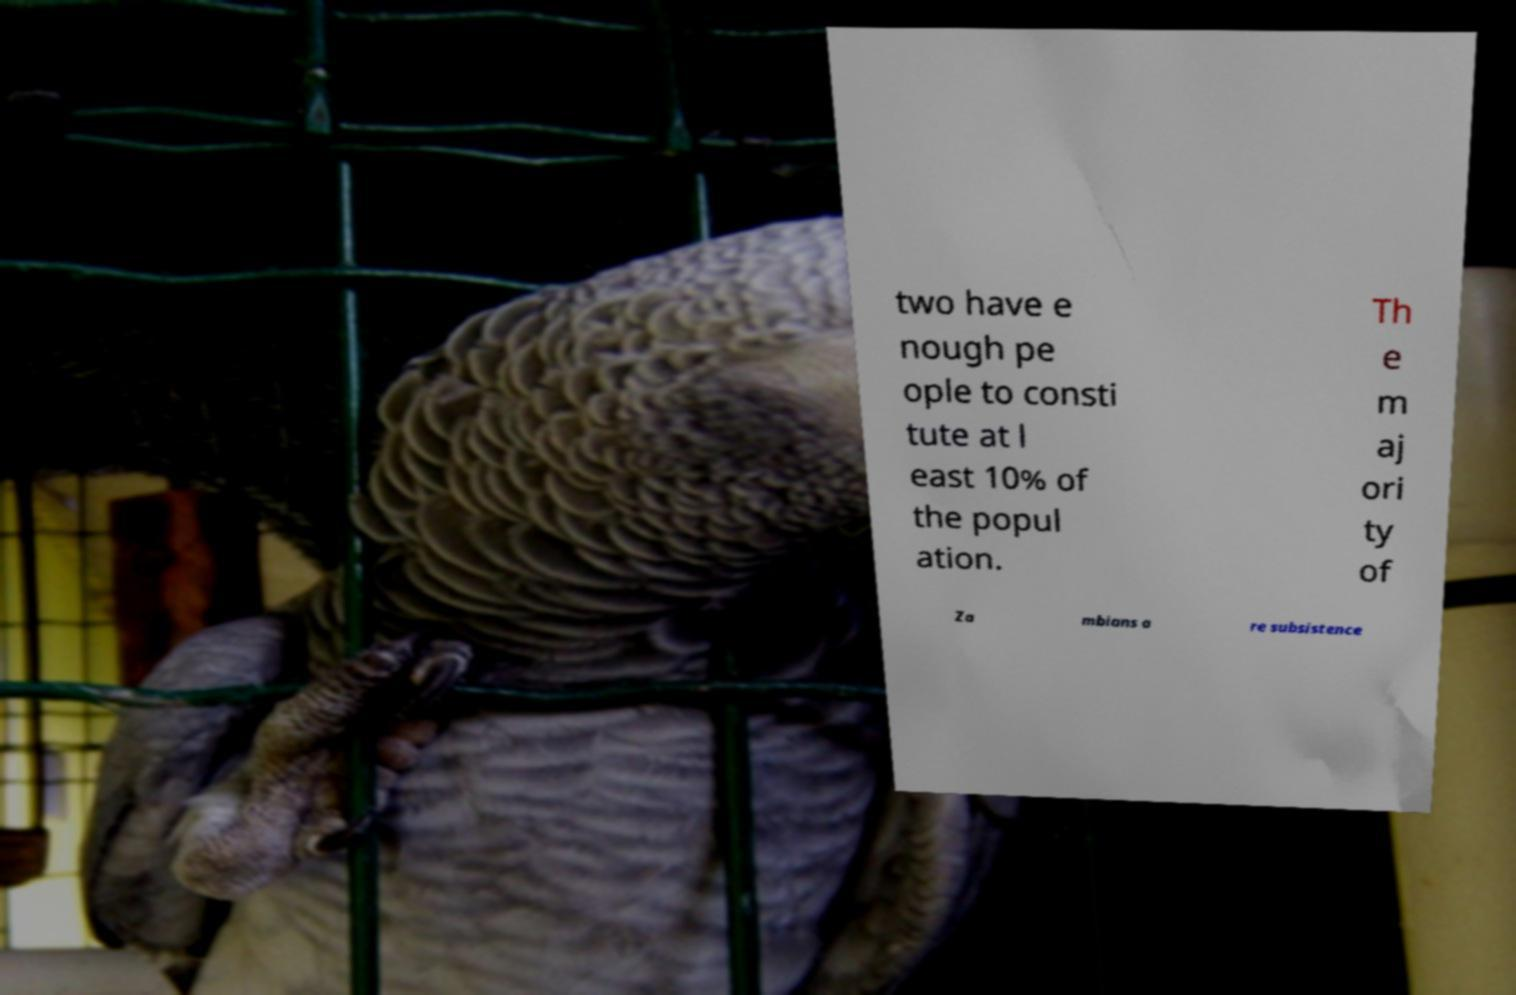Could you extract and type out the text from this image? two have e nough pe ople to consti tute at l east 10% of the popul ation. Th e m aj ori ty of Za mbians a re subsistence 